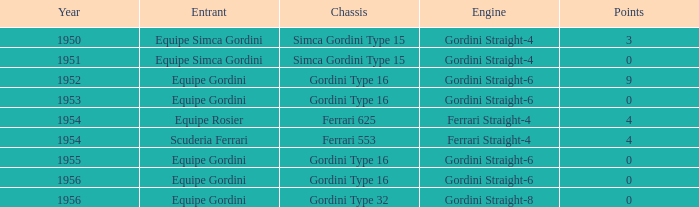What engine was used by Equipe Simca Gordini before 1956 with less than 4 points? Gordini Straight-4, Gordini Straight-4. 